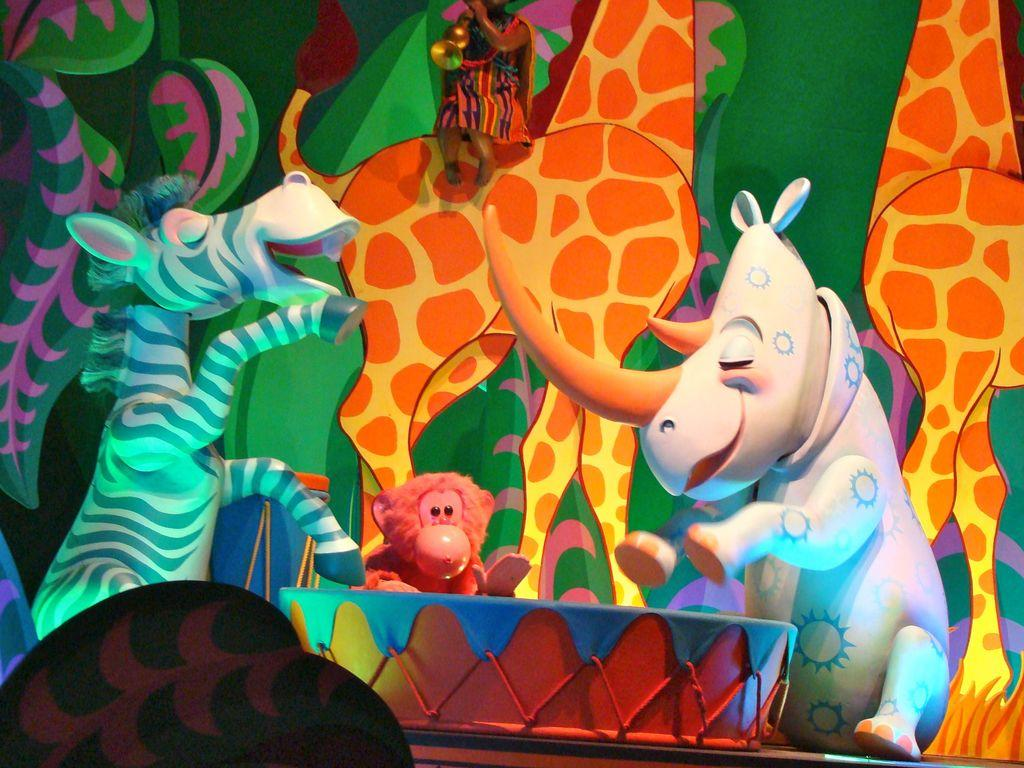What type of objects are depicted in the image? There are cartoon statues of animals in the image. Where are the statues located? The statues are standing on a stage. Can you name some of the animal statues in the image? There is a statue of a zebra, a hippopotamus, a monkey, and a giraffe. What other object is present on the stage? There is a drum on the stage. What type of yarn is being used to create the cartoon statues in the image? There is no yarn present in the image; the statues are depicted as cartoons, not made of yarn. 